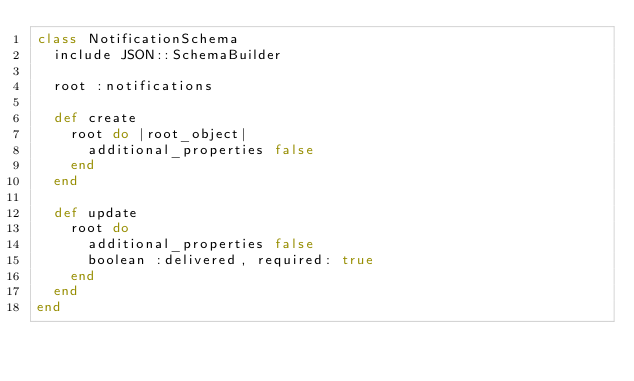Convert code to text. <code><loc_0><loc_0><loc_500><loc_500><_Ruby_>class NotificationSchema
  include JSON::SchemaBuilder

  root :notifications

  def create
    root do |root_object|
      additional_properties false
    end
  end

  def update
    root do
      additional_properties false
      boolean :delivered, required: true
    end
  end
end
</code> 